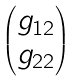Convert formula to latex. <formula><loc_0><loc_0><loc_500><loc_500>\begin{pmatrix} g _ { 1 2 } \\ g _ { 2 2 } \end{pmatrix}</formula> 